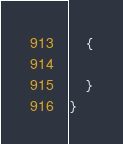<code> <loc_0><loc_0><loc_500><loc_500><_C#_>    {

    }
}</code> 